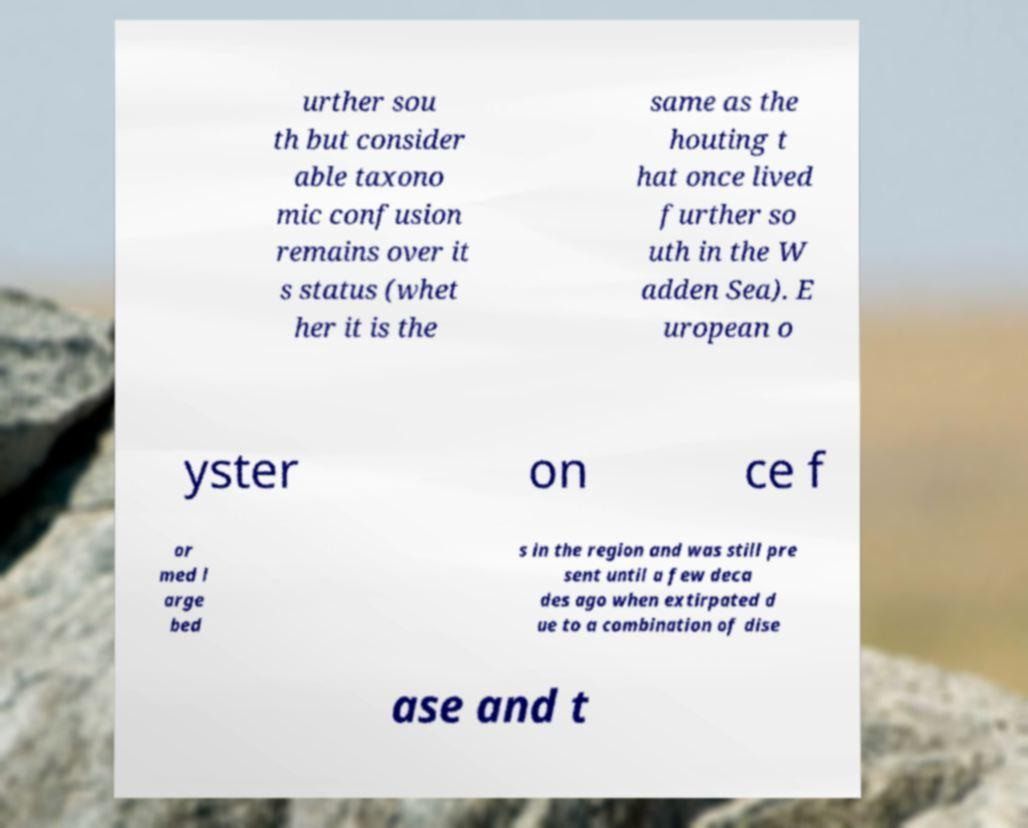Please read and relay the text visible in this image. What does it say? urther sou th but consider able taxono mic confusion remains over it s status (whet her it is the same as the houting t hat once lived further so uth in the W adden Sea). E uropean o yster on ce f or med l arge bed s in the region and was still pre sent until a few deca des ago when extirpated d ue to a combination of dise ase and t 